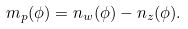<formula> <loc_0><loc_0><loc_500><loc_500>m _ { p } ( \phi ) = n _ { w } ( \phi ) - n _ { z } ( \phi ) .</formula> 